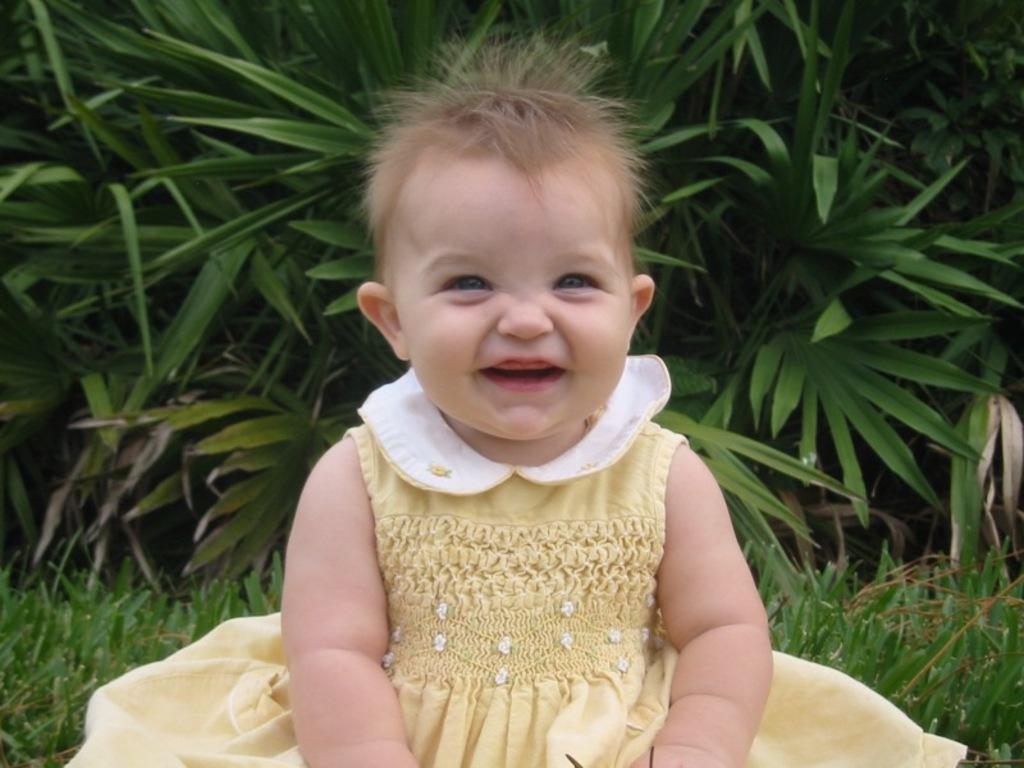Who is the main subject in the image? There is a small girl in the image. What is the girl doing in the image? The girl is sitting and smiling. What type of surface is visible beneath the girl? There is grass visible in the image. What can be seen in the background of the image? In the background, there are plants that are green in color. What position does the manager hold in the image? There is no manager present in the image; it features a small girl sitting and smiling. What type of paint is used to color the girl's hair in the image? There is no paint visible in the image, as it is a photograph of a real girl. 